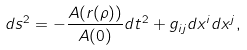<formula> <loc_0><loc_0><loc_500><loc_500>d s ^ { 2 } = - \frac { A ( r ( \rho ) ) } { A ( 0 ) } d t ^ { 2 } + g _ { i j } d x ^ { i } d x ^ { j } ,</formula> 